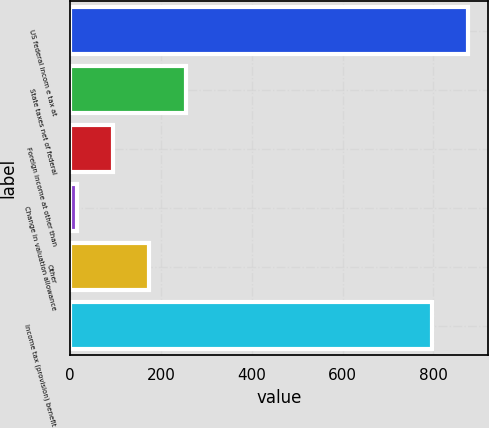Convert chart to OTSL. <chart><loc_0><loc_0><loc_500><loc_500><bar_chart><fcel>US federal incom e tax at<fcel>State taxes net of federal<fcel>Foreign income at other than<fcel>Change in valuation allowance<fcel>Other<fcel>Income tax (provision) benefit<nl><fcel>876.26<fcel>254.08<fcel>94.96<fcel>15.4<fcel>174.52<fcel>796.7<nl></chart> 